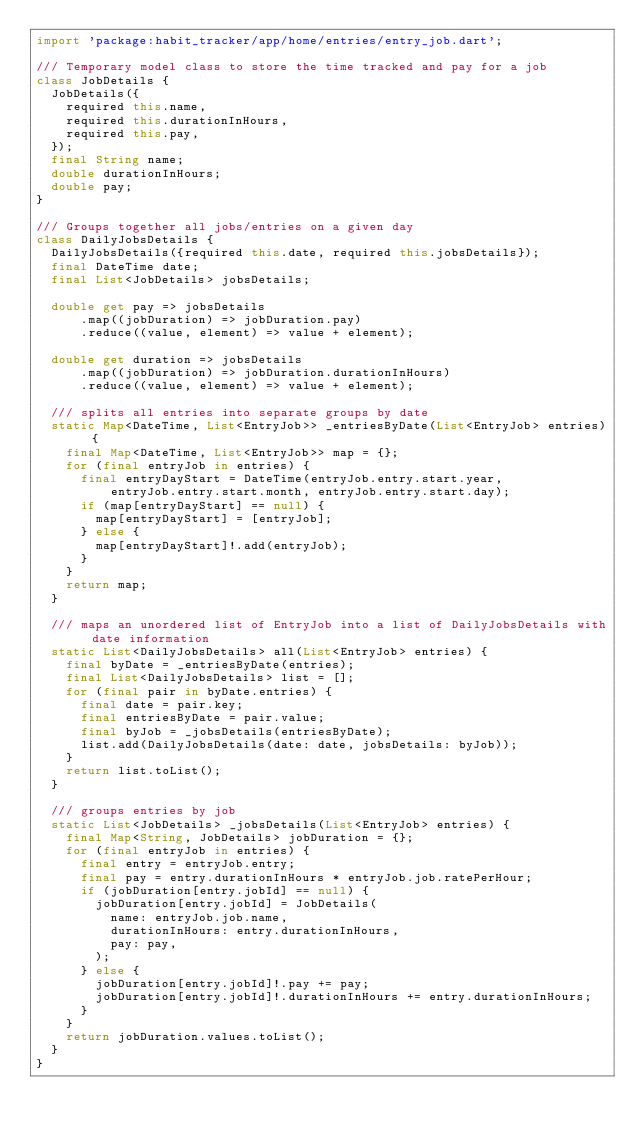Convert code to text. <code><loc_0><loc_0><loc_500><loc_500><_Dart_>import 'package:habit_tracker/app/home/entries/entry_job.dart';

/// Temporary model class to store the time tracked and pay for a job
class JobDetails {
  JobDetails({
    required this.name,
    required this.durationInHours,
    required this.pay,
  });
  final String name;
  double durationInHours;
  double pay;
}

/// Groups together all jobs/entries on a given day
class DailyJobsDetails {
  DailyJobsDetails({required this.date, required this.jobsDetails});
  final DateTime date;
  final List<JobDetails> jobsDetails;

  double get pay => jobsDetails
      .map((jobDuration) => jobDuration.pay)
      .reduce((value, element) => value + element);

  double get duration => jobsDetails
      .map((jobDuration) => jobDuration.durationInHours)
      .reduce((value, element) => value + element);

  /// splits all entries into separate groups by date
  static Map<DateTime, List<EntryJob>> _entriesByDate(List<EntryJob> entries) {
    final Map<DateTime, List<EntryJob>> map = {};
    for (final entryJob in entries) {
      final entryDayStart = DateTime(entryJob.entry.start.year,
          entryJob.entry.start.month, entryJob.entry.start.day);
      if (map[entryDayStart] == null) {
        map[entryDayStart] = [entryJob];
      } else {
        map[entryDayStart]!.add(entryJob);
      }
    }
    return map;
  }

  /// maps an unordered list of EntryJob into a list of DailyJobsDetails with date information
  static List<DailyJobsDetails> all(List<EntryJob> entries) {
    final byDate = _entriesByDate(entries);
    final List<DailyJobsDetails> list = [];
    for (final pair in byDate.entries) {
      final date = pair.key;
      final entriesByDate = pair.value;
      final byJob = _jobsDetails(entriesByDate);
      list.add(DailyJobsDetails(date: date, jobsDetails: byJob));
    }
    return list.toList();
  }

  /// groups entries by job
  static List<JobDetails> _jobsDetails(List<EntryJob> entries) {
    final Map<String, JobDetails> jobDuration = {};
    for (final entryJob in entries) {
      final entry = entryJob.entry;
      final pay = entry.durationInHours * entryJob.job.ratePerHour;
      if (jobDuration[entry.jobId] == null) {
        jobDuration[entry.jobId] = JobDetails(
          name: entryJob.job.name,
          durationInHours: entry.durationInHours,
          pay: pay,
        );
      } else {
        jobDuration[entry.jobId]!.pay += pay;
        jobDuration[entry.jobId]!.durationInHours += entry.durationInHours;
      }
    }
    return jobDuration.values.toList();
  }
}
</code> 